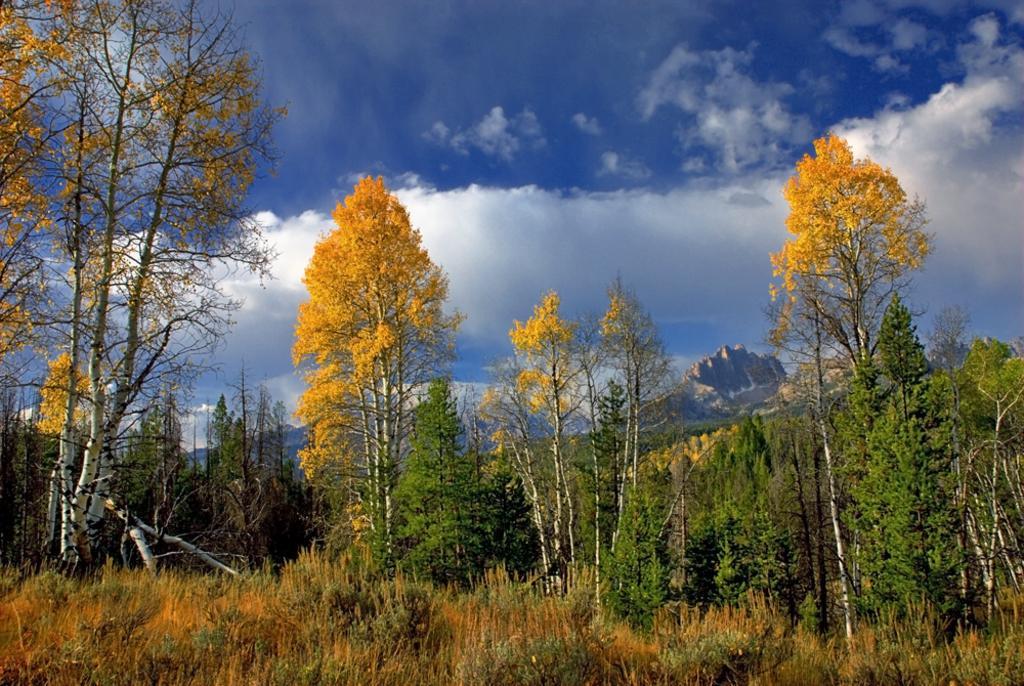Can you describe this image briefly? Here in this picture we can see the ground is fully covered with grass, plants and trees and in the far we can see mountains present and we can see clouds in the sky. 